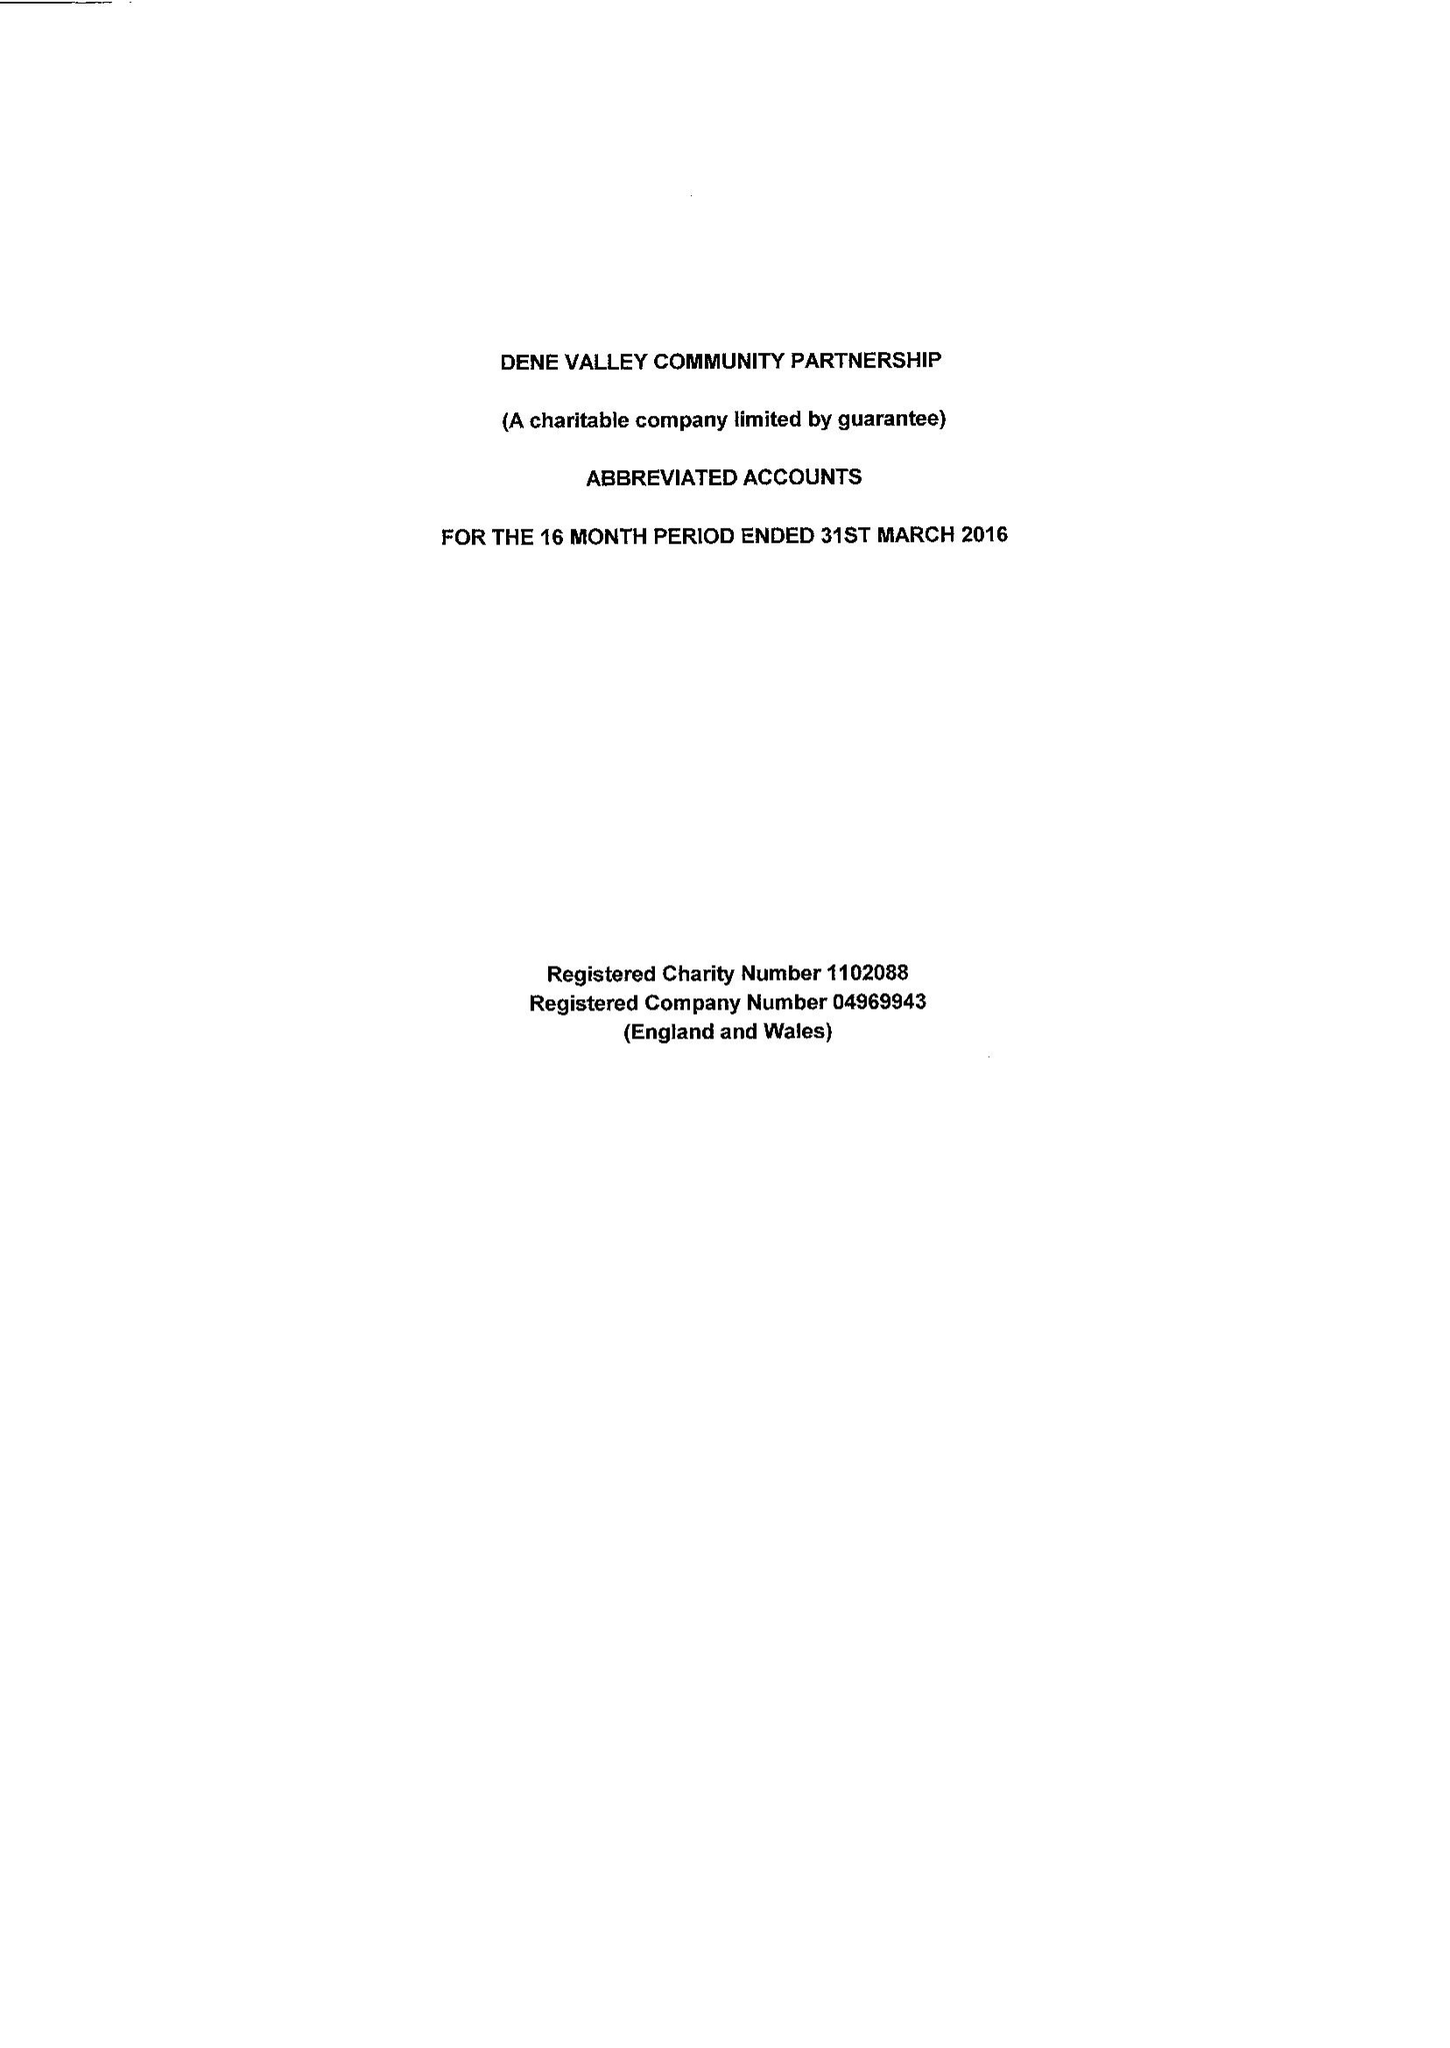What is the value for the charity_number?
Answer the question using a single word or phrase. 1102088 